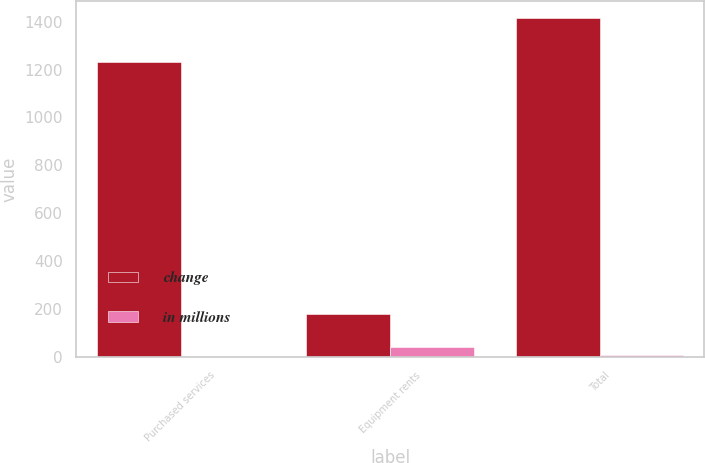Convert chart. <chart><loc_0><loc_0><loc_500><loc_500><stacked_bar_chart><ecel><fcel>Purchased services<fcel>Equipment rents<fcel>Total<nl><fcel>change<fcel>1233<fcel>181<fcel>1414<nl><fcel>in millions<fcel>1<fcel>41<fcel>9<nl></chart> 